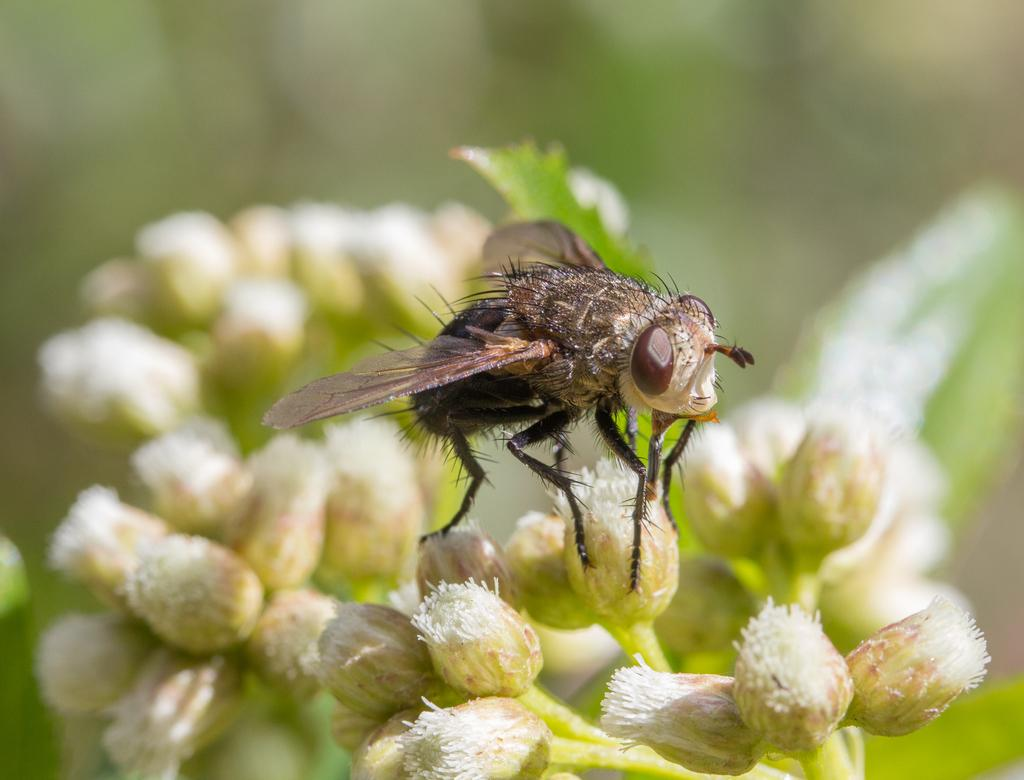What is present in the image? There is a fly in the image. What is the fly standing on? The fly is standing on flowers. What are the flowers part of? The flowers are part of a plant. What type of truck can be seen in the image? There is no truck present in the image; it features a fly standing on flowers that are part of a plant. How many points does the fly have on its wings in the image? Flies do not have points on their wings; they have a membranous structure. 